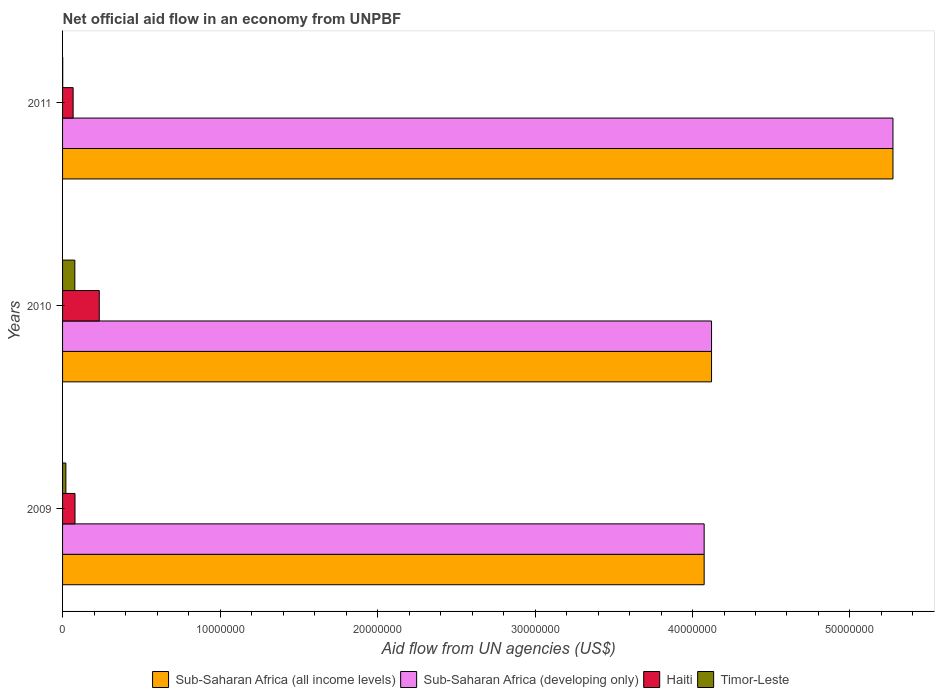How many groups of bars are there?
Your answer should be compact. 3. Are the number of bars per tick equal to the number of legend labels?
Keep it short and to the point. Yes. Are the number of bars on each tick of the Y-axis equal?
Give a very brief answer. Yes. What is the label of the 2nd group of bars from the top?
Provide a short and direct response. 2010. What is the net official aid flow in Haiti in 2010?
Your response must be concise. 2.33e+06. Across all years, what is the maximum net official aid flow in Sub-Saharan Africa (all income levels)?
Your answer should be compact. 5.27e+07. Across all years, what is the minimum net official aid flow in Sub-Saharan Africa (developing only)?
Give a very brief answer. 4.07e+07. In which year was the net official aid flow in Sub-Saharan Africa (all income levels) maximum?
Your answer should be compact. 2011. What is the total net official aid flow in Haiti in the graph?
Offer a very short reply. 3.79e+06. What is the difference between the net official aid flow in Timor-Leste in 2009 and that in 2011?
Your answer should be compact. 2.00e+05. What is the difference between the net official aid flow in Sub-Saharan Africa (developing only) in 2009 and the net official aid flow in Timor-Leste in 2011?
Offer a terse response. 4.07e+07. What is the average net official aid flow in Sub-Saharan Africa (all income levels) per year?
Keep it short and to the point. 4.49e+07. In the year 2011, what is the difference between the net official aid flow in Sub-Saharan Africa (all income levels) and net official aid flow in Haiti?
Ensure brevity in your answer.  5.21e+07. What is the ratio of the net official aid flow in Sub-Saharan Africa (all income levels) in 2010 to that in 2011?
Make the answer very short. 0.78. Is the net official aid flow in Sub-Saharan Africa (all income levels) in 2009 less than that in 2011?
Offer a terse response. Yes. Is the difference between the net official aid flow in Sub-Saharan Africa (all income levels) in 2010 and 2011 greater than the difference between the net official aid flow in Haiti in 2010 and 2011?
Your answer should be compact. No. What is the difference between the highest and the second highest net official aid flow in Sub-Saharan Africa (all income levels)?
Keep it short and to the point. 1.15e+07. What is the difference between the highest and the lowest net official aid flow in Haiti?
Offer a very short reply. 1.66e+06. What does the 3rd bar from the top in 2010 represents?
Your answer should be very brief. Sub-Saharan Africa (developing only). What does the 4th bar from the bottom in 2009 represents?
Provide a short and direct response. Timor-Leste. Are all the bars in the graph horizontal?
Your response must be concise. Yes. How many years are there in the graph?
Give a very brief answer. 3. What is the difference between two consecutive major ticks on the X-axis?
Provide a short and direct response. 1.00e+07. Are the values on the major ticks of X-axis written in scientific E-notation?
Offer a terse response. No. Does the graph contain any zero values?
Ensure brevity in your answer.  No. Does the graph contain grids?
Offer a very short reply. No. How many legend labels are there?
Offer a very short reply. 4. How are the legend labels stacked?
Ensure brevity in your answer.  Horizontal. What is the title of the graph?
Offer a terse response. Net official aid flow in an economy from UNPBF. What is the label or title of the X-axis?
Your answer should be very brief. Aid flow from UN agencies (US$). What is the label or title of the Y-axis?
Your answer should be compact. Years. What is the Aid flow from UN agencies (US$) of Sub-Saharan Africa (all income levels) in 2009?
Offer a very short reply. 4.07e+07. What is the Aid flow from UN agencies (US$) in Sub-Saharan Africa (developing only) in 2009?
Your answer should be very brief. 4.07e+07. What is the Aid flow from UN agencies (US$) in Haiti in 2009?
Offer a very short reply. 7.90e+05. What is the Aid flow from UN agencies (US$) in Sub-Saharan Africa (all income levels) in 2010?
Give a very brief answer. 4.12e+07. What is the Aid flow from UN agencies (US$) in Sub-Saharan Africa (developing only) in 2010?
Provide a short and direct response. 4.12e+07. What is the Aid flow from UN agencies (US$) in Haiti in 2010?
Offer a very short reply. 2.33e+06. What is the Aid flow from UN agencies (US$) in Timor-Leste in 2010?
Offer a terse response. 7.80e+05. What is the Aid flow from UN agencies (US$) of Sub-Saharan Africa (all income levels) in 2011?
Provide a short and direct response. 5.27e+07. What is the Aid flow from UN agencies (US$) of Sub-Saharan Africa (developing only) in 2011?
Provide a succinct answer. 5.27e+07. What is the Aid flow from UN agencies (US$) of Haiti in 2011?
Provide a succinct answer. 6.70e+05. Across all years, what is the maximum Aid flow from UN agencies (US$) in Sub-Saharan Africa (all income levels)?
Keep it short and to the point. 5.27e+07. Across all years, what is the maximum Aid flow from UN agencies (US$) of Sub-Saharan Africa (developing only)?
Provide a succinct answer. 5.27e+07. Across all years, what is the maximum Aid flow from UN agencies (US$) in Haiti?
Your answer should be very brief. 2.33e+06. Across all years, what is the maximum Aid flow from UN agencies (US$) of Timor-Leste?
Offer a very short reply. 7.80e+05. Across all years, what is the minimum Aid flow from UN agencies (US$) of Sub-Saharan Africa (all income levels)?
Provide a succinct answer. 4.07e+07. Across all years, what is the minimum Aid flow from UN agencies (US$) of Sub-Saharan Africa (developing only)?
Offer a very short reply. 4.07e+07. Across all years, what is the minimum Aid flow from UN agencies (US$) in Haiti?
Provide a succinct answer. 6.70e+05. Across all years, what is the minimum Aid flow from UN agencies (US$) of Timor-Leste?
Offer a terse response. 10000. What is the total Aid flow from UN agencies (US$) of Sub-Saharan Africa (all income levels) in the graph?
Offer a very short reply. 1.35e+08. What is the total Aid flow from UN agencies (US$) in Sub-Saharan Africa (developing only) in the graph?
Provide a succinct answer. 1.35e+08. What is the total Aid flow from UN agencies (US$) of Haiti in the graph?
Make the answer very short. 3.79e+06. What is the difference between the Aid flow from UN agencies (US$) in Sub-Saharan Africa (all income levels) in 2009 and that in 2010?
Make the answer very short. -4.70e+05. What is the difference between the Aid flow from UN agencies (US$) of Sub-Saharan Africa (developing only) in 2009 and that in 2010?
Provide a succinct answer. -4.70e+05. What is the difference between the Aid flow from UN agencies (US$) in Haiti in 2009 and that in 2010?
Your answer should be very brief. -1.54e+06. What is the difference between the Aid flow from UN agencies (US$) of Timor-Leste in 2009 and that in 2010?
Your answer should be compact. -5.70e+05. What is the difference between the Aid flow from UN agencies (US$) of Sub-Saharan Africa (all income levels) in 2009 and that in 2011?
Give a very brief answer. -1.20e+07. What is the difference between the Aid flow from UN agencies (US$) of Sub-Saharan Africa (developing only) in 2009 and that in 2011?
Provide a succinct answer. -1.20e+07. What is the difference between the Aid flow from UN agencies (US$) in Sub-Saharan Africa (all income levels) in 2010 and that in 2011?
Provide a short and direct response. -1.15e+07. What is the difference between the Aid flow from UN agencies (US$) in Sub-Saharan Africa (developing only) in 2010 and that in 2011?
Offer a very short reply. -1.15e+07. What is the difference between the Aid flow from UN agencies (US$) in Haiti in 2010 and that in 2011?
Keep it short and to the point. 1.66e+06. What is the difference between the Aid flow from UN agencies (US$) in Timor-Leste in 2010 and that in 2011?
Ensure brevity in your answer.  7.70e+05. What is the difference between the Aid flow from UN agencies (US$) in Sub-Saharan Africa (all income levels) in 2009 and the Aid flow from UN agencies (US$) in Sub-Saharan Africa (developing only) in 2010?
Your answer should be very brief. -4.70e+05. What is the difference between the Aid flow from UN agencies (US$) in Sub-Saharan Africa (all income levels) in 2009 and the Aid flow from UN agencies (US$) in Haiti in 2010?
Provide a short and direct response. 3.84e+07. What is the difference between the Aid flow from UN agencies (US$) of Sub-Saharan Africa (all income levels) in 2009 and the Aid flow from UN agencies (US$) of Timor-Leste in 2010?
Provide a succinct answer. 4.00e+07. What is the difference between the Aid flow from UN agencies (US$) of Sub-Saharan Africa (developing only) in 2009 and the Aid flow from UN agencies (US$) of Haiti in 2010?
Provide a short and direct response. 3.84e+07. What is the difference between the Aid flow from UN agencies (US$) in Sub-Saharan Africa (developing only) in 2009 and the Aid flow from UN agencies (US$) in Timor-Leste in 2010?
Ensure brevity in your answer.  4.00e+07. What is the difference between the Aid flow from UN agencies (US$) of Haiti in 2009 and the Aid flow from UN agencies (US$) of Timor-Leste in 2010?
Give a very brief answer. 10000. What is the difference between the Aid flow from UN agencies (US$) of Sub-Saharan Africa (all income levels) in 2009 and the Aid flow from UN agencies (US$) of Sub-Saharan Africa (developing only) in 2011?
Make the answer very short. -1.20e+07. What is the difference between the Aid flow from UN agencies (US$) in Sub-Saharan Africa (all income levels) in 2009 and the Aid flow from UN agencies (US$) in Haiti in 2011?
Provide a short and direct response. 4.01e+07. What is the difference between the Aid flow from UN agencies (US$) in Sub-Saharan Africa (all income levels) in 2009 and the Aid flow from UN agencies (US$) in Timor-Leste in 2011?
Give a very brief answer. 4.07e+07. What is the difference between the Aid flow from UN agencies (US$) in Sub-Saharan Africa (developing only) in 2009 and the Aid flow from UN agencies (US$) in Haiti in 2011?
Your answer should be very brief. 4.01e+07. What is the difference between the Aid flow from UN agencies (US$) of Sub-Saharan Africa (developing only) in 2009 and the Aid flow from UN agencies (US$) of Timor-Leste in 2011?
Your answer should be compact. 4.07e+07. What is the difference between the Aid flow from UN agencies (US$) in Haiti in 2009 and the Aid flow from UN agencies (US$) in Timor-Leste in 2011?
Give a very brief answer. 7.80e+05. What is the difference between the Aid flow from UN agencies (US$) in Sub-Saharan Africa (all income levels) in 2010 and the Aid flow from UN agencies (US$) in Sub-Saharan Africa (developing only) in 2011?
Your answer should be very brief. -1.15e+07. What is the difference between the Aid flow from UN agencies (US$) in Sub-Saharan Africa (all income levels) in 2010 and the Aid flow from UN agencies (US$) in Haiti in 2011?
Offer a very short reply. 4.05e+07. What is the difference between the Aid flow from UN agencies (US$) of Sub-Saharan Africa (all income levels) in 2010 and the Aid flow from UN agencies (US$) of Timor-Leste in 2011?
Your answer should be compact. 4.12e+07. What is the difference between the Aid flow from UN agencies (US$) of Sub-Saharan Africa (developing only) in 2010 and the Aid flow from UN agencies (US$) of Haiti in 2011?
Offer a terse response. 4.05e+07. What is the difference between the Aid flow from UN agencies (US$) in Sub-Saharan Africa (developing only) in 2010 and the Aid flow from UN agencies (US$) in Timor-Leste in 2011?
Offer a very short reply. 4.12e+07. What is the difference between the Aid flow from UN agencies (US$) in Haiti in 2010 and the Aid flow from UN agencies (US$) in Timor-Leste in 2011?
Your answer should be very brief. 2.32e+06. What is the average Aid flow from UN agencies (US$) of Sub-Saharan Africa (all income levels) per year?
Make the answer very short. 4.49e+07. What is the average Aid flow from UN agencies (US$) in Sub-Saharan Africa (developing only) per year?
Offer a very short reply. 4.49e+07. What is the average Aid flow from UN agencies (US$) in Haiti per year?
Keep it short and to the point. 1.26e+06. What is the average Aid flow from UN agencies (US$) in Timor-Leste per year?
Offer a terse response. 3.33e+05. In the year 2009, what is the difference between the Aid flow from UN agencies (US$) in Sub-Saharan Africa (all income levels) and Aid flow from UN agencies (US$) in Sub-Saharan Africa (developing only)?
Keep it short and to the point. 0. In the year 2009, what is the difference between the Aid flow from UN agencies (US$) in Sub-Saharan Africa (all income levels) and Aid flow from UN agencies (US$) in Haiti?
Your answer should be compact. 4.00e+07. In the year 2009, what is the difference between the Aid flow from UN agencies (US$) in Sub-Saharan Africa (all income levels) and Aid flow from UN agencies (US$) in Timor-Leste?
Provide a succinct answer. 4.05e+07. In the year 2009, what is the difference between the Aid flow from UN agencies (US$) of Sub-Saharan Africa (developing only) and Aid flow from UN agencies (US$) of Haiti?
Provide a succinct answer. 4.00e+07. In the year 2009, what is the difference between the Aid flow from UN agencies (US$) in Sub-Saharan Africa (developing only) and Aid flow from UN agencies (US$) in Timor-Leste?
Provide a short and direct response. 4.05e+07. In the year 2009, what is the difference between the Aid flow from UN agencies (US$) in Haiti and Aid flow from UN agencies (US$) in Timor-Leste?
Offer a very short reply. 5.80e+05. In the year 2010, what is the difference between the Aid flow from UN agencies (US$) of Sub-Saharan Africa (all income levels) and Aid flow from UN agencies (US$) of Sub-Saharan Africa (developing only)?
Make the answer very short. 0. In the year 2010, what is the difference between the Aid flow from UN agencies (US$) of Sub-Saharan Africa (all income levels) and Aid flow from UN agencies (US$) of Haiti?
Provide a succinct answer. 3.89e+07. In the year 2010, what is the difference between the Aid flow from UN agencies (US$) of Sub-Saharan Africa (all income levels) and Aid flow from UN agencies (US$) of Timor-Leste?
Ensure brevity in your answer.  4.04e+07. In the year 2010, what is the difference between the Aid flow from UN agencies (US$) of Sub-Saharan Africa (developing only) and Aid flow from UN agencies (US$) of Haiti?
Your answer should be compact. 3.89e+07. In the year 2010, what is the difference between the Aid flow from UN agencies (US$) in Sub-Saharan Africa (developing only) and Aid flow from UN agencies (US$) in Timor-Leste?
Provide a succinct answer. 4.04e+07. In the year 2010, what is the difference between the Aid flow from UN agencies (US$) of Haiti and Aid flow from UN agencies (US$) of Timor-Leste?
Provide a succinct answer. 1.55e+06. In the year 2011, what is the difference between the Aid flow from UN agencies (US$) in Sub-Saharan Africa (all income levels) and Aid flow from UN agencies (US$) in Sub-Saharan Africa (developing only)?
Keep it short and to the point. 0. In the year 2011, what is the difference between the Aid flow from UN agencies (US$) in Sub-Saharan Africa (all income levels) and Aid flow from UN agencies (US$) in Haiti?
Give a very brief answer. 5.21e+07. In the year 2011, what is the difference between the Aid flow from UN agencies (US$) in Sub-Saharan Africa (all income levels) and Aid flow from UN agencies (US$) in Timor-Leste?
Give a very brief answer. 5.27e+07. In the year 2011, what is the difference between the Aid flow from UN agencies (US$) in Sub-Saharan Africa (developing only) and Aid flow from UN agencies (US$) in Haiti?
Provide a short and direct response. 5.21e+07. In the year 2011, what is the difference between the Aid flow from UN agencies (US$) of Sub-Saharan Africa (developing only) and Aid flow from UN agencies (US$) of Timor-Leste?
Give a very brief answer. 5.27e+07. What is the ratio of the Aid flow from UN agencies (US$) in Haiti in 2009 to that in 2010?
Offer a terse response. 0.34. What is the ratio of the Aid flow from UN agencies (US$) of Timor-Leste in 2009 to that in 2010?
Offer a very short reply. 0.27. What is the ratio of the Aid flow from UN agencies (US$) in Sub-Saharan Africa (all income levels) in 2009 to that in 2011?
Give a very brief answer. 0.77. What is the ratio of the Aid flow from UN agencies (US$) in Sub-Saharan Africa (developing only) in 2009 to that in 2011?
Ensure brevity in your answer.  0.77. What is the ratio of the Aid flow from UN agencies (US$) of Haiti in 2009 to that in 2011?
Ensure brevity in your answer.  1.18. What is the ratio of the Aid flow from UN agencies (US$) of Timor-Leste in 2009 to that in 2011?
Your answer should be very brief. 21. What is the ratio of the Aid flow from UN agencies (US$) in Sub-Saharan Africa (all income levels) in 2010 to that in 2011?
Your answer should be very brief. 0.78. What is the ratio of the Aid flow from UN agencies (US$) of Sub-Saharan Africa (developing only) in 2010 to that in 2011?
Make the answer very short. 0.78. What is the ratio of the Aid flow from UN agencies (US$) in Haiti in 2010 to that in 2011?
Give a very brief answer. 3.48. What is the ratio of the Aid flow from UN agencies (US$) in Timor-Leste in 2010 to that in 2011?
Keep it short and to the point. 78. What is the difference between the highest and the second highest Aid flow from UN agencies (US$) of Sub-Saharan Africa (all income levels)?
Keep it short and to the point. 1.15e+07. What is the difference between the highest and the second highest Aid flow from UN agencies (US$) in Sub-Saharan Africa (developing only)?
Keep it short and to the point. 1.15e+07. What is the difference between the highest and the second highest Aid flow from UN agencies (US$) of Haiti?
Provide a short and direct response. 1.54e+06. What is the difference between the highest and the second highest Aid flow from UN agencies (US$) in Timor-Leste?
Provide a short and direct response. 5.70e+05. What is the difference between the highest and the lowest Aid flow from UN agencies (US$) of Sub-Saharan Africa (all income levels)?
Your response must be concise. 1.20e+07. What is the difference between the highest and the lowest Aid flow from UN agencies (US$) of Sub-Saharan Africa (developing only)?
Ensure brevity in your answer.  1.20e+07. What is the difference between the highest and the lowest Aid flow from UN agencies (US$) in Haiti?
Offer a terse response. 1.66e+06. What is the difference between the highest and the lowest Aid flow from UN agencies (US$) in Timor-Leste?
Give a very brief answer. 7.70e+05. 